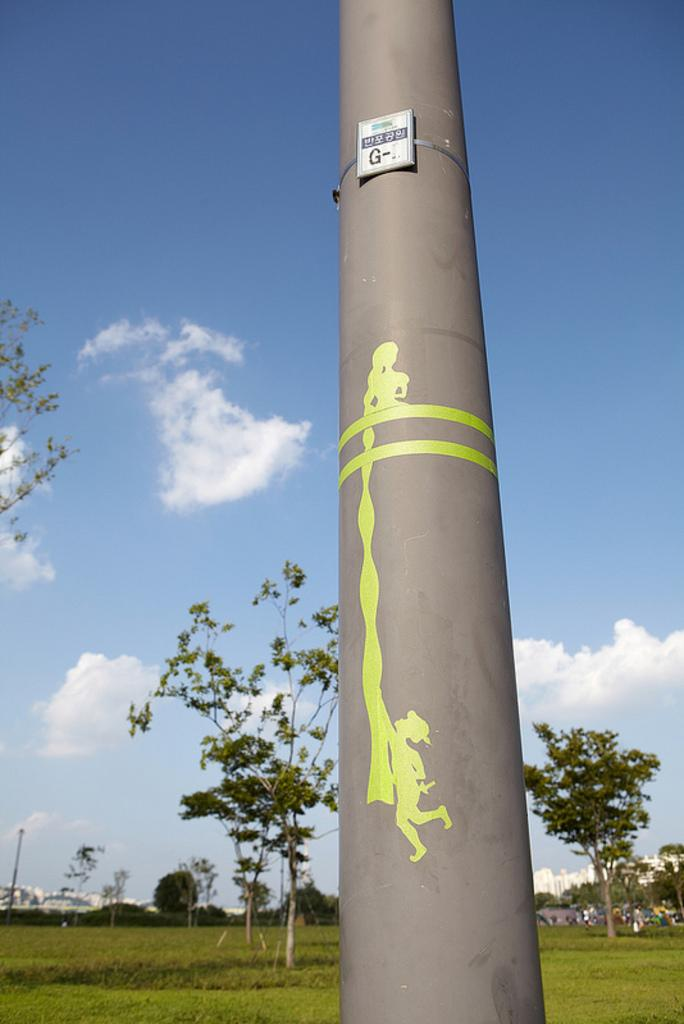What is the main structure in the image? There is a pillar in the image. What is attached to the pillar? There is a board on the pillar. What decorations are on the pillar? There are stickers on the pillar. What can be seen in the background of the image? There are trees, plants, grass, buildings, and a cloudy sky visible in the background of the image. What type of apparatus is being used to measure the height of the pillar in the image? There is no apparatus present in the image for measuring the height of the pillar. How many sticks are visible in the image? There are no sticks visible in the image. 